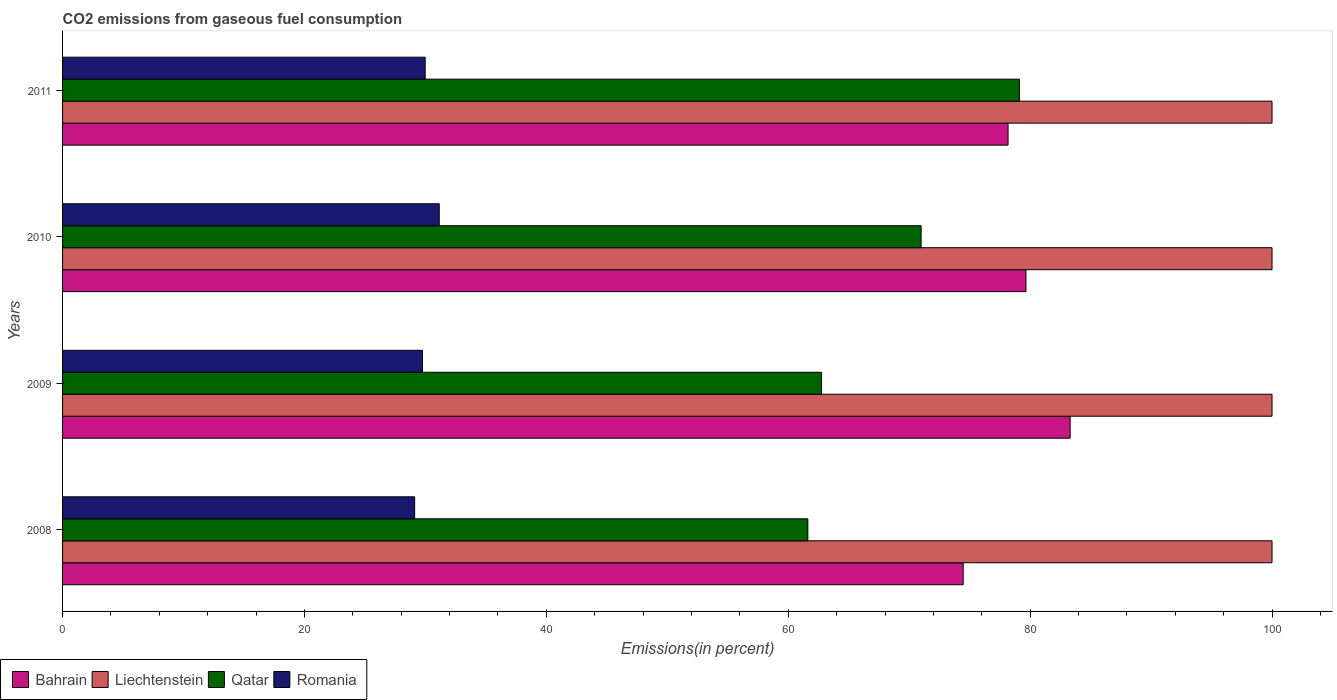Are the number of bars on each tick of the Y-axis equal?
Provide a succinct answer. Yes. How many bars are there on the 1st tick from the bottom?
Offer a terse response. 4. In how many cases, is the number of bars for a given year not equal to the number of legend labels?
Offer a terse response. 0. What is the total CO2 emitted in Bahrain in 2009?
Offer a terse response. 83.31. Across all years, what is the minimum total CO2 emitted in Qatar?
Your response must be concise. 61.62. In which year was the total CO2 emitted in Romania maximum?
Make the answer very short. 2010. In which year was the total CO2 emitted in Romania minimum?
Provide a succinct answer. 2008. What is the total total CO2 emitted in Bahrain in the graph?
Make the answer very short. 315.61. What is the difference between the total CO2 emitted in Liechtenstein in 2009 and that in 2011?
Provide a short and direct response. 0. What is the difference between the total CO2 emitted in Liechtenstein in 2010 and the total CO2 emitted in Bahrain in 2011?
Make the answer very short. 21.82. What is the average total CO2 emitted in Liechtenstein per year?
Offer a terse response. 100. In the year 2008, what is the difference between the total CO2 emitted in Bahrain and total CO2 emitted in Liechtenstein?
Offer a terse response. -25.53. In how many years, is the total CO2 emitted in Liechtenstein greater than 32 %?
Offer a very short reply. 4. What is the ratio of the total CO2 emitted in Bahrain in 2009 to that in 2011?
Ensure brevity in your answer.  1.07. Is the difference between the total CO2 emitted in Bahrain in 2008 and 2010 greater than the difference between the total CO2 emitted in Liechtenstein in 2008 and 2010?
Give a very brief answer. No. What is the difference between the highest and the second highest total CO2 emitted in Qatar?
Make the answer very short. 8.12. What is the difference between the highest and the lowest total CO2 emitted in Qatar?
Provide a succinct answer. 17.49. Is the sum of the total CO2 emitted in Romania in 2008 and 2009 greater than the maximum total CO2 emitted in Bahrain across all years?
Give a very brief answer. No. What does the 1st bar from the top in 2010 represents?
Offer a terse response. Romania. What does the 2nd bar from the bottom in 2010 represents?
Your response must be concise. Liechtenstein. Is it the case that in every year, the sum of the total CO2 emitted in Qatar and total CO2 emitted in Bahrain is greater than the total CO2 emitted in Liechtenstein?
Offer a very short reply. Yes. Does the graph contain any zero values?
Your response must be concise. No. How are the legend labels stacked?
Ensure brevity in your answer.  Horizontal. What is the title of the graph?
Offer a terse response. CO2 emissions from gaseous fuel consumption. What is the label or title of the X-axis?
Provide a succinct answer. Emissions(in percent). What is the Emissions(in percent) in Bahrain in 2008?
Your answer should be compact. 74.47. What is the Emissions(in percent) of Liechtenstein in 2008?
Keep it short and to the point. 100. What is the Emissions(in percent) of Qatar in 2008?
Your answer should be compact. 61.62. What is the Emissions(in percent) of Romania in 2008?
Offer a very short reply. 29.11. What is the Emissions(in percent) in Bahrain in 2009?
Your answer should be compact. 83.31. What is the Emissions(in percent) of Liechtenstein in 2009?
Your answer should be very brief. 100. What is the Emissions(in percent) in Qatar in 2009?
Keep it short and to the point. 62.75. What is the Emissions(in percent) of Romania in 2009?
Your answer should be very brief. 29.76. What is the Emissions(in percent) of Bahrain in 2010?
Your response must be concise. 79.66. What is the Emissions(in percent) in Qatar in 2010?
Ensure brevity in your answer.  70.99. What is the Emissions(in percent) of Romania in 2010?
Make the answer very short. 31.14. What is the Emissions(in percent) in Bahrain in 2011?
Make the answer very short. 78.18. What is the Emissions(in percent) of Liechtenstein in 2011?
Offer a very short reply. 100. What is the Emissions(in percent) of Qatar in 2011?
Keep it short and to the point. 79.11. What is the Emissions(in percent) of Romania in 2011?
Your response must be concise. 29.98. Across all years, what is the maximum Emissions(in percent) of Bahrain?
Your answer should be very brief. 83.31. Across all years, what is the maximum Emissions(in percent) of Qatar?
Make the answer very short. 79.11. Across all years, what is the maximum Emissions(in percent) in Romania?
Keep it short and to the point. 31.14. Across all years, what is the minimum Emissions(in percent) of Bahrain?
Keep it short and to the point. 74.47. Across all years, what is the minimum Emissions(in percent) of Qatar?
Provide a succinct answer. 61.62. Across all years, what is the minimum Emissions(in percent) of Romania?
Offer a very short reply. 29.11. What is the total Emissions(in percent) in Bahrain in the graph?
Your answer should be compact. 315.61. What is the total Emissions(in percent) in Liechtenstein in the graph?
Offer a terse response. 400. What is the total Emissions(in percent) of Qatar in the graph?
Provide a short and direct response. 274.47. What is the total Emissions(in percent) in Romania in the graph?
Keep it short and to the point. 120. What is the difference between the Emissions(in percent) in Bahrain in 2008 and that in 2009?
Keep it short and to the point. -8.84. What is the difference between the Emissions(in percent) in Qatar in 2008 and that in 2009?
Your response must be concise. -1.13. What is the difference between the Emissions(in percent) in Romania in 2008 and that in 2009?
Provide a succinct answer. -0.65. What is the difference between the Emissions(in percent) of Bahrain in 2008 and that in 2010?
Your answer should be very brief. -5.19. What is the difference between the Emissions(in percent) of Qatar in 2008 and that in 2010?
Ensure brevity in your answer.  -9.37. What is the difference between the Emissions(in percent) of Romania in 2008 and that in 2010?
Make the answer very short. -2.03. What is the difference between the Emissions(in percent) of Bahrain in 2008 and that in 2011?
Provide a short and direct response. -3.71. What is the difference between the Emissions(in percent) in Liechtenstein in 2008 and that in 2011?
Offer a very short reply. 0. What is the difference between the Emissions(in percent) in Qatar in 2008 and that in 2011?
Offer a very short reply. -17.49. What is the difference between the Emissions(in percent) in Romania in 2008 and that in 2011?
Offer a very short reply. -0.87. What is the difference between the Emissions(in percent) in Bahrain in 2009 and that in 2010?
Give a very brief answer. 3.65. What is the difference between the Emissions(in percent) of Qatar in 2009 and that in 2010?
Offer a terse response. -8.24. What is the difference between the Emissions(in percent) of Romania in 2009 and that in 2010?
Keep it short and to the point. -1.38. What is the difference between the Emissions(in percent) of Bahrain in 2009 and that in 2011?
Your response must be concise. 5.13. What is the difference between the Emissions(in percent) in Liechtenstein in 2009 and that in 2011?
Your answer should be very brief. 0. What is the difference between the Emissions(in percent) in Qatar in 2009 and that in 2011?
Keep it short and to the point. -16.36. What is the difference between the Emissions(in percent) in Romania in 2009 and that in 2011?
Keep it short and to the point. -0.22. What is the difference between the Emissions(in percent) of Bahrain in 2010 and that in 2011?
Keep it short and to the point. 1.48. What is the difference between the Emissions(in percent) of Liechtenstein in 2010 and that in 2011?
Give a very brief answer. 0. What is the difference between the Emissions(in percent) of Qatar in 2010 and that in 2011?
Your answer should be very brief. -8.12. What is the difference between the Emissions(in percent) in Romania in 2010 and that in 2011?
Your answer should be very brief. 1.16. What is the difference between the Emissions(in percent) in Bahrain in 2008 and the Emissions(in percent) in Liechtenstein in 2009?
Your answer should be very brief. -25.53. What is the difference between the Emissions(in percent) of Bahrain in 2008 and the Emissions(in percent) of Qatar in 2009?
Provide a succinct answer. 11.72. What is the difference between the Emissions(in percent) of Bahrain in 2008 and the Emissions(in percent) of Romania in 2009?
Your response must be concise. 44.71. What is the difference between the Emissions(in percent) of Liechtenstein in 2008 and the Emissions(in percent) of Qatar in 2009?
Offer a terse response. 37.25. What is the difference between the Emissions(in percent) in Liechtenstein in 2008 and the Emissions(in percent) in Romania in 2009?
Make the answer very short. 70.24. What is the difference between the Emissions(in percent) of Qatar in 2008 and the Emissions(in percent) of Romania in 2009?
Provide a succinct answer. 31.86. What is the difference between the Emissions(in percent) in Bahrain in 2008 and the Emissions(in percent) in Liechtenstein in 2010?
Offer a very short reply. -25.53. What is the difference between the Emissions(in percent) in Bahrain in 2008 and the Emissions(in percent) in Qatar in 2010?
Provide a succinct answer. 3.48. What is the difference between the Emissions(in percent) in Bahrain in 2008 and the Emissions(in percent) in Romania in 2010?
Ensure brevity in your answer.  43.32. What is the difference between the Emissions(in percent) of Liechtenstein in 2008 and the Emissions(in percent) of Qatar in 2010?
Keep it short and to the point. 29.01. What is the difference between the Emissions(in percent) in Liechtenstein in 2008 and the Emissions(in percent) in Romania in 2010?
Ensure brevity in your answer.  68.86. What is the difference between the Emissions(in percent) in Qatar in 2008 and the Emissions(in percent) in Romania in 2010?
Your answer should be compact. 30.48. What is the difference between the Emissions(in percent) of Bahrain in 2008 and the Emissions(in percent) of Liechtenstein in 2011?
Ensure brevity in your answer.  -25.53. What is the difference between the Emissions(in percent) in Bahrain in 2008 and the Emissions(in percent) in Qatar in 2011?
Provide a succinct answer. -4.65. What is the difference between the Emissions(in percent) of Bahrain in 2008 and the Emissions(in percent) of Romania in 2011?
Your answer should be very brief. 44.48. What is the difference between the Emissions(in percent) in Liechtenstein in 2008 and the Emissions(in percent) in Qatar in 2011?
Make the answer very short. 20.89. What is the difference between the Emissions(in percent) in Liechtenstein in 2008 and the Emissions(in percent) in Romania in 2011?
Your answer should be very brief. 70.02. What is the difference between the Emissions(in percent) in Qatar in 2008 and the Emissions(in percent) in Romania in 2011?
Keep it short and to the point. 31.64. What is the difference between the Emissions(in percent) in Bahrain in 2009 and the Emissions(in percent) in Liechtenstein in 2010?
Provide a short and direct response. -16.69. What is the difference between the Emissions(in percent) of Bahrain in 2009 and the Emissions(in percent) of Qatar in 2010?
Your answer should be compact. 12.32. What is the difference between the Emissions(in percent) in Bahrain in 2009 and the Emissions(in percent) in Romania in 2010?
Keep it short and to the point. 52.16. What is the difference between the Emissions(in percent) of Liechtenstein in 2009 and the Emissions(in percent) of Qatar in 2010?
Your response must be concise. 29.01. What is the difference between the Emissions(in percent) of Liechtenstein in 2009 and the Emissions(in percent) of Romania in 2010?
Offer a very short reply. 68.86. What is the difference between the Emissions(in percent) of Qatar in 2009 and the Emissions(in percent) of Romania in 2010?
Ensure brevity in your answer.  31.61. What is the difference between the Emissions(in percent) of Bahrain in 2009 and the Emissions(in percent) of Liechtenstein in 2011?
Your answer should be very brief. -16.69. What is the difference between the Emissions(in percent) of Bahrain in 2009 and the Emissions(in percent) of Qatar in 2011?
Offer a very short reply. 4.2. What is the difference between the Emissions(in percent) of Bahrain in 2009 and the Emissions(in percent) of Romania in 2011?
Your answer should be compact. 53.33. What is the difference between the Emissions(in percent) in Liechtenstein in 2009 and the Emissions(in percent) in Qatar in 2011?
Offer a very short reply. 20.89. What is the difference between the Emissions(in percent) in Liechtenstein in 2009 and the Emissions(in percent) in Romania in 2011?
Give a very brief answer. 70.02. What is the difference between the Emissions(in percent) in Qatar in 2009 and the Emissions(in percent) in Romania in 2011?
Ensure brevity in your answer.  32.77. What is the difference between the Emissions(in percent) of Bahrain in 2010 and the Emissions(in percent) of Liechtenstein in 2011?
Keep it short and to the point. -20.34. What is the difference between the Emissions(in percent) of Bahrain in 2010 and the Emissions(in percent) of Qatar in 2011?
Make the answer very short. 0.55. What is the difference between the Emissions(in percent) in Bahrain in 2010 and the Emissions(in percent) in Romania in 2011?
Your response must be concise. 49.67. What is the difference between the Emissions(in percent) of Liechtenstein in 2010 and the Emissions(in percent) of Qatar in 2011?
Your response must be concise. 20.89. What is the difference between the Emissions(in percent) of Liechtenstein in 2010 and the Emissions(in percent) of Romania in 2011?
Provide a succinct answer. 70.02. What is the difference between the Emissions(in percent) in Qatar in 2010 and the Emissions(in percent) in Romania in 2011?
Make the answer very short. 41.01. What is the average Emissions(in percent) of Bahrain per year?
Give a very brief answer. 78.9. What is the average Emissions(in percent) of Qatar per year?
Ensure brevity in your answer.  68.62. What is the average Emissions(in percent) in Romania per year?
Your response must be concise. 30. In the year 2008, what is the difference between the Emissions(in percent) of Bahrain and Emissions(in percent) of Liechtenstein?
Give a very brief answer. -25.53. In the year 2008, what is the difference between the Emissions(in percent) of Bahrain and Emissions(in percent) of Qatar?
Your answer should be compact. 12.84. In the year 2008, what is the difference between the Emissions(in percent) of Bahrain and Emissions(in percent) of Romania?
Your answer should be very brief. 45.35. In the year 2008, what is the difference between the Emissions(in percent) in Liechtenstein and Emissions(in percent) in Qatar?
Make the answer very short. 38.38. In the year 2008, what is the difference between the Emissions(in percent) in Liechtenstein and Emissions(in percent) in Romania?
Your response must be concise. 70.89. In the year 2008, what is the difference between the Emissions(in percent) of Qatar and Emissions(in percent) of Romania?
Provide a short and direct response. 32.51. In the year 2009, what is the difference between the Emissions(in percent) in Bahrain and Emissions(in percent) in Liechtenstein?
Offer a terse response. -16.69. In the year 2009, what is the difference between the Emissions(in percent) of Bahrain and Emissions(in percent) of Qatar?
Offer a very short reply. 20.56. In the year 2009, what is the difference between the Emissions(in percent) in Bahrain and Emissions(in percent) in Romania?
Offer a very short reply. 53.55. In the year 2009, what is the difference between the Emissions(in percent) in Liechtenstein and Emissions(in percent) in Qatar?
Your answer should be compact. 37.25. In the year 2009, what is the difference between the Emissions(in percent) in Liechtenstein and Emissions(in percent) in Romania?
Make the answer very short. 70.24. In the year 2009, what is the difference between the Emissions(in percent) in Qatar and Emissions(in percent) in Romania?
Make the answer very short. 32.99. In the year 2010, what is the difference between the Emissions(in percent) in Bahrain and Emissions(in percent) in Liechtenstein?
Make the answer very short. -20.34. In the year 2010, what is the difference between the Emissions(in percent) in Bahrain and Emissions(in percent) in Qatar?
Your response must be concise. 8.67. In the year 2010, what is the difference between the Emissions(in percent) in Bahrain and Emissions(in percent) in Romania?
Offer a terse response. 48.51. In the year 2010, what is the difference between the Emissions(in percent) in Liechtenstein and Emissions(in percent) in Qatar?
Ensure brevity in your answer.  29.01. In the year 2010, what is the difference between the Emissions(in percent) of Liechtenstein and Emissions(in percent) of Romania?
Offer a terse response. 68.86. In the year 2010, what is the difference between the Emissions(in percent) of Qatar and Emissions(in percent) of Romania?
Ensure brevity in your answer.  39.84. In the year 2011, what is the difference between the Emissions(in percent) of Bahrain and Emissions(in percent) of Liechtenstein?
Offer a very short reply. -21.82. In the year 2011, what is the difference between the Emissions(in percent) of Bahrain and Emissions(in percent) of Qatar?
Provide a succinct answer. -0.93. In the year 2011, what is the difference between the Emissions(in percent) of Bahrain and Emissions(in percent) of Romania?
Offer a terse response. 48.19. In the year 2011, what is the difference between the Emissions(in percent) of Liechtenstein and Emissions(in percent) of Qatar?
Ensure brevity in your answer.  20.89. In the year 2011, what is the difference between the Emissions(in percent) in Liechtenstein and Emissions(in percent) in Romania?
Make the answer very short. 70.02. In the year 2011, what is the difference between the Emissions(in percent) of Qatar and Emissions(in percent) of Romania?
Your answer should be very brief. 49.13. What is the ratio of the Emissions(in percent) in Bahrain in 2008 to that in 2009?
Provide a short and direct response. 0.89. What is the ratio of the Emissions(in percent) of Qatar in 2008 to that in 2009?
Your response must be concise. 0.98. What is the ratio of the Emissions(in percent) of Romania in 2008 to that in 2009?
Make the answer very short. 0.98. What is the ratio of the Emissions(in percent) in Bahrain in 2008 to that in 2010?
Provide a short and direct response. 0.93. What is the ratio of the Emissions(in percent) of Liechtenstein in 2008 to that in 2010?
Ensure brevity in your answer.  1. What is the ratio of the Emissions(in percent) of Qatar in 2008 to that in 2010?
Offer a very short reply. 0.87. What is the ratio of the Emissions(in percent) in Romania in 2008 to that in 2010?
Offer a very short reply. 0.93. What is the ratio of the Emissions(in percent) in Bahrain in 2008 to that in 2011?
Your answer should be compact. 0.95. What is the ratio of the Emissions(in percent) of Qatar in 2008 to that in 2011?
Keep it short and to the point. 0.78. What is the ratio of the Emissions(in percent) in Bahrain in 2009 to that in 2010?
Make the answer very short. 1.05. What is the ratio of the Emissions(in percent) in Qatar in 2009 to that in 2010?
Make the answer very short. 0.88. What is the ratio of the Emissions(in percent) in Romania in 2009 to that in 2010?
Ensure brevity in your answer.  0.96. What is the ratio of the Emissions(in percent) of Bahrain in 2009 to that in 2011?
Your answer should be compact. 1.07. What is the ratio of the Emissions(in percent) in Qatar in 2009 to that in 2011?
Ensure brevity in your answer.  0.79. What is the ratio of the Emissions(in percent) in Bahrain in 2010 to that in 2011?
Your response must be concise. 1.02. What is the ratio of the Emissions(in percent) of Qatar in 2010 to that in 2011?
Offer a terse response. 0.9. What is the ratio of the Emissions(in percent) in Romania in 2010 to that in 2011?
Offer a terse response. 1.04. What is the difference between the highest and the second highest Emissions(in percent) of Bahrain?
Give a very brief answer. 3.65. What is the difference between the highest and the second highest Emissions(in percent) of Qatar?
Offer a terse response. 8.12. What is the difference between the highest and the second highest Emissions(in percent) in Romania?
Your answer should be very brief. 1.16. What is the difference between the highest and the lowest Emissions(in percent) of Bahrain?
Provide a succinct answer. 8.84. What is the difference between the highest and the lowest Emissions(in percent) in Liechtenstein?
Ensure brevity in your answer.  0. What is the difference between the highest and the lowest Emissions(in percent) in Qatar?
Give a very brief answer. 17.49. What is the difference between the highest and the lowest Emissions(in percent) of Romania?
Provide a short and direct response. 2.03. 